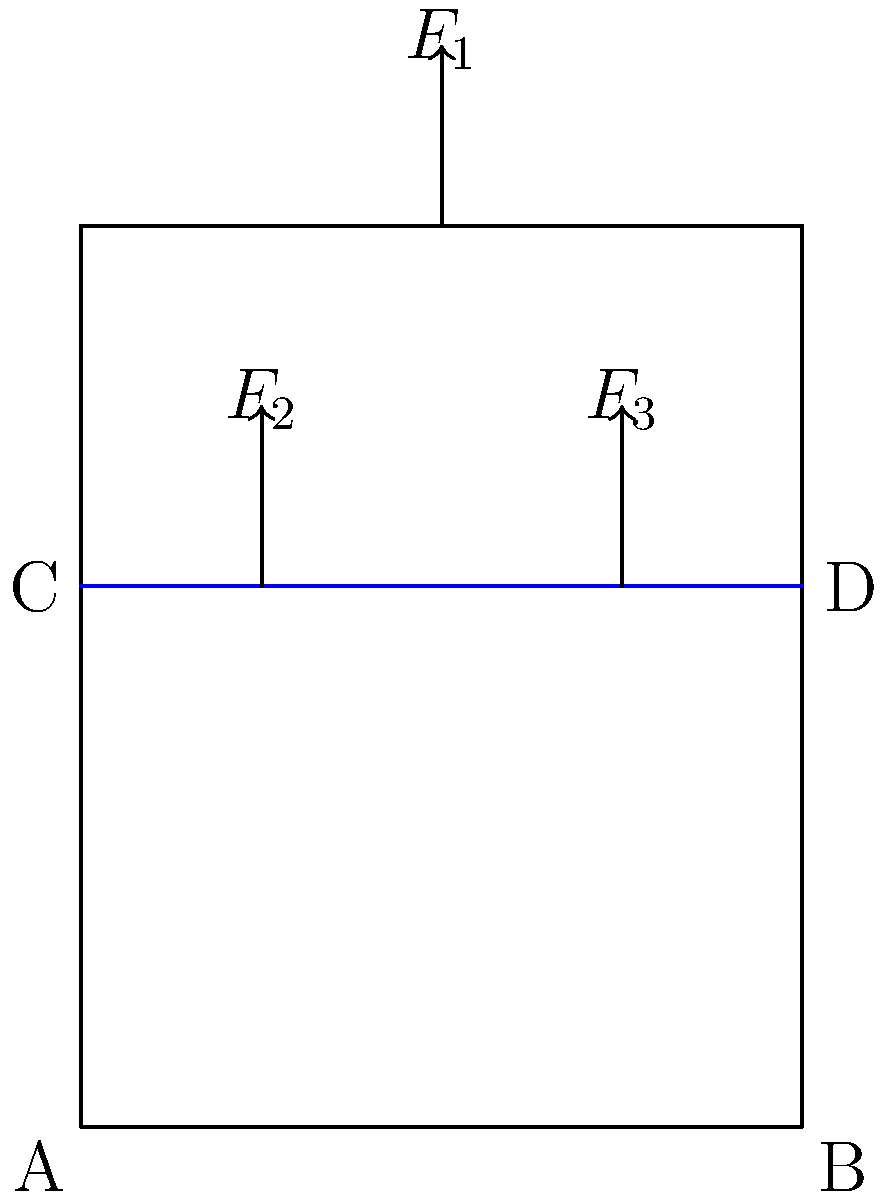A handcrafted wooden chair is subjected to three vertical loads: $F_1 = 500$ N at the center of the backrest, and $F_2 = F_3 = 250$ N on the seat, as shown in the diagram. Assuming the chair legs (AB and CD) are fixed to the ground, calculate the maximum bending stress in the seat (CD) if it has a rectangular cross-section with width 8 cm and height 2 cm. To find the maximum bending stress in the seat, we'll follow these steps:

1. Calculate the reaction forces at points C and D:
   The total load on the seat is $F_2 + F_3 = 250 + 250 = 500$ N
   Due to symmetry, each reaction force will be half of this: $R_C = R_D = 250$ N

2. Determine the bending moment at the center of the seat:
   $M = F_2 \cdot 0.3 \text{ m} = 250 \text{ N} \cdot 0.3 \text{ m} = 75 \text{ N}\cdot\text{m}$

3. Calculate the moment of inertia for the rectangular cross-section:
   $I = \frac{1}{12}bh^3 = \frac{1}{12} \cdot 0.08 \text{ m} \cdot (0.02 \text{ m})^3 = 5.33 \times 10^{-8} \text{ m}^4$

4. Find the distance from the neutral axis to the outermost fiber:
   $y = \frac{h}{2} = \frac{0.02 \text{ m}}{2} = 0.01 \text{ m}$

5. Apply the flexure formula to calculate the maximum bending stress:
   $$\sigma_{max} = \frac{My}{I} = \frac{75 \text{ N}\cdot\text{m} \cdot 0.01 \text{ m}}{5.33 \times 10^{-8} \text{ m}^4} = 14.07 \times 10^6 \text{ Pa} = 14.07 \text{ MPa}$$
Answer: 14.07 MPa 